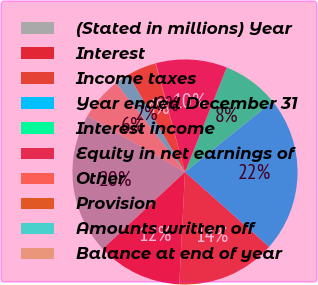Convert chart. <chart><loc_0><loc_0><loc_500><loc_500><pie_chart><fcel>(Stated in millions) Year<fcel>Interest<fcel>Income taxes<fcel>Year ended December 31<fcel>Interest income<fcel>Equity in net earnings of<fcel>Other<fcel>Provision<fcel>Amounts written off<fcel>Balance at end of year<nl><fcel>20.31%<fcel>12.22%<fcel>14.25%<fcel>22.34%<fcel>8.18%<fcel>10.2%<fcel>0.09%<fcel>4.14%<fcel>2.11%<fcel>6.16%<nl></chart> 